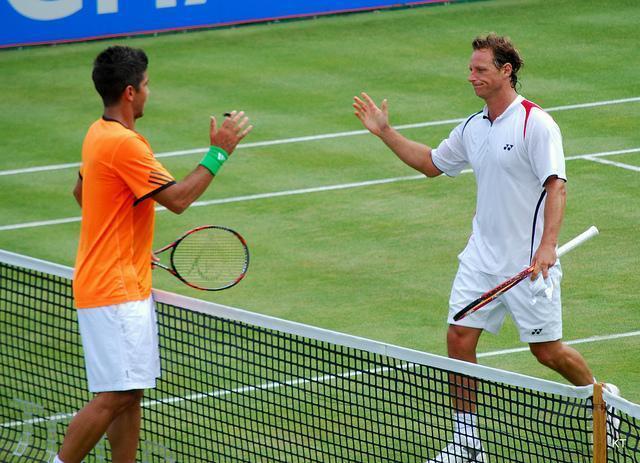How many tennis rackets are in the picture?
Give a very brief answer. 1. How many people are visible?
Give a very brief answer. 2. 